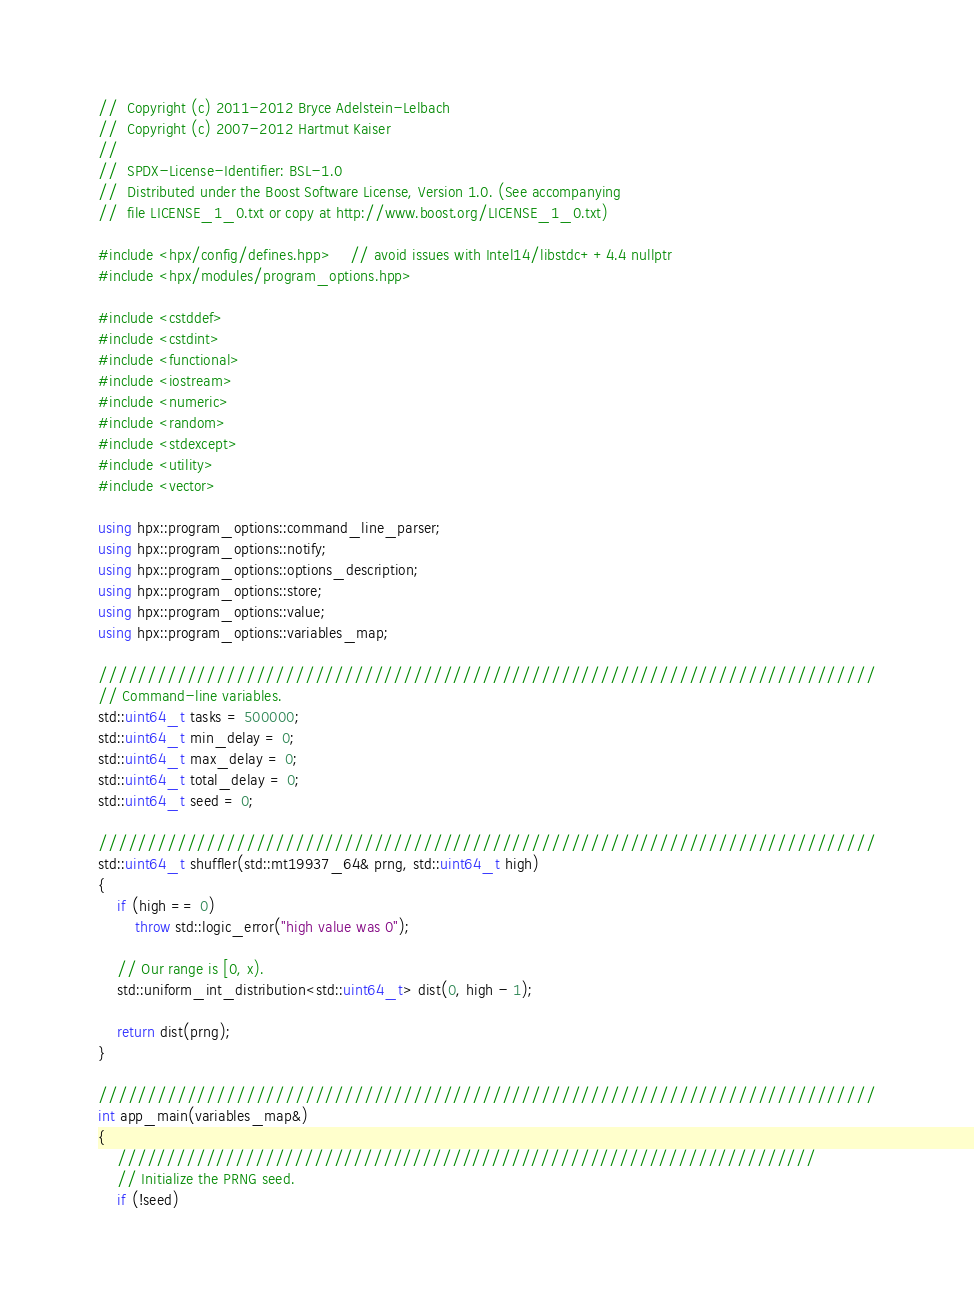Convert code to text. <code><loc_0><loc_0><loc_500><loc_500><_C++_>//  Copyright (c) 2011-2012 Bryce Adelstein-Lelbach
//  Copyright (c) 2007-2012 Hartmut Kaiser
//
//  SPDX-License-Identifier: BSL-1.0
//  Distributed under the Boost Software License, Version 1.0. (See accompanying
//  file LICENSE_1_0.txt or copy at http://www.boost.org/LICENSE_1_0.txt)

#include <hpx/config/defines.hpp>    // avoid issues with Intel14/libstdc++4.4 nullptr
#include <hpx/modules/program_options.hpp>

#include <cstddef>
#include <cstdint>
#include <functional>
#include <iostream>
#include <numeric>
#include <random>
#include <stdexcept>
#include <utility>
#include <vector>

using hpx::program_options::command_line_parser;
using hpx::program_options::notify;
using hpx::program_options::options_description;
using hpx::program_options::store;
using hpx::program_options::value;
using hpx::program_options::variables_map;

///////////////////////////////////////////////////////////////////////////////
// Command-line variables.
std::uint64_t tasks = 500000;
std::uint64_t min_delay = 0;
std::uint64_t max_delay = 0;
std::uint64_t total_delay = 0;
std::uint64_t seed = 0;

///////////////////////////////////////////////////////////////////////////////
std::uint64_t shuffler(std::mt19937_64& prng, std::uint64_t high)
{
    if (high == 0)
        throw std::logic_error("high value was 0");

    // Our range is [0, x).
    std::uniform_int_distribution<std::uint64_t> dist(0, high - 1);

    return dist(prng);
}

///////////////////////////////////////////////////////////////////////////////
int app_main(variables_map&)
{
    ///////////////////////////////////////////////////////////////////////
    // Initialize the PRNG seed.
    if (!seed)</code> 